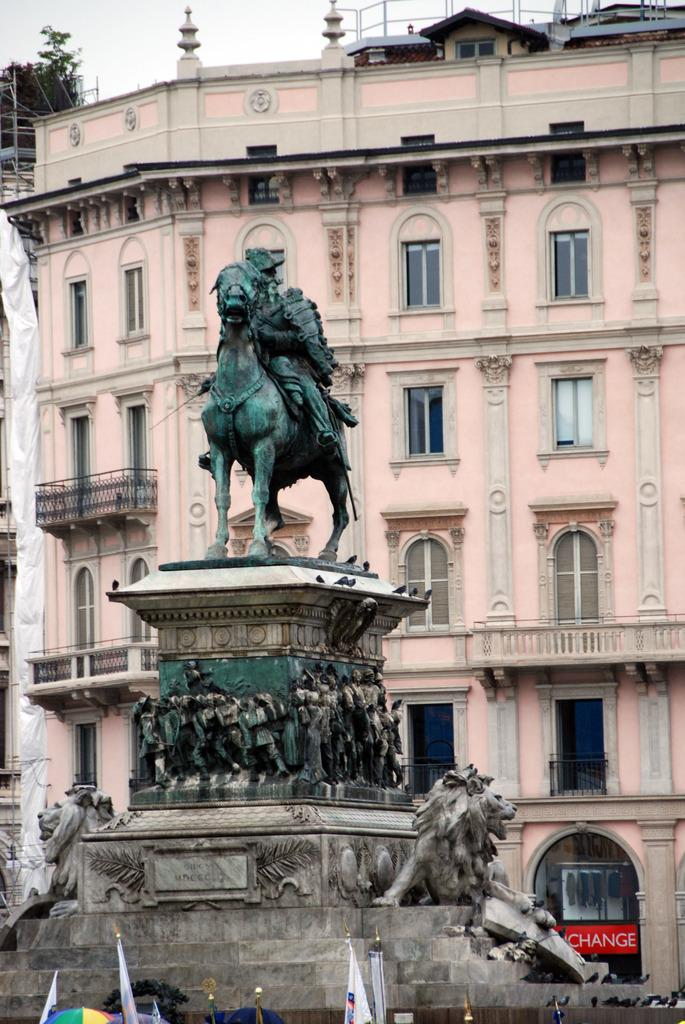<image>
Render a clear and concise summary of the photo. An elaborate statue stands in front of a pink building with a red sign that says "change" at street level. 